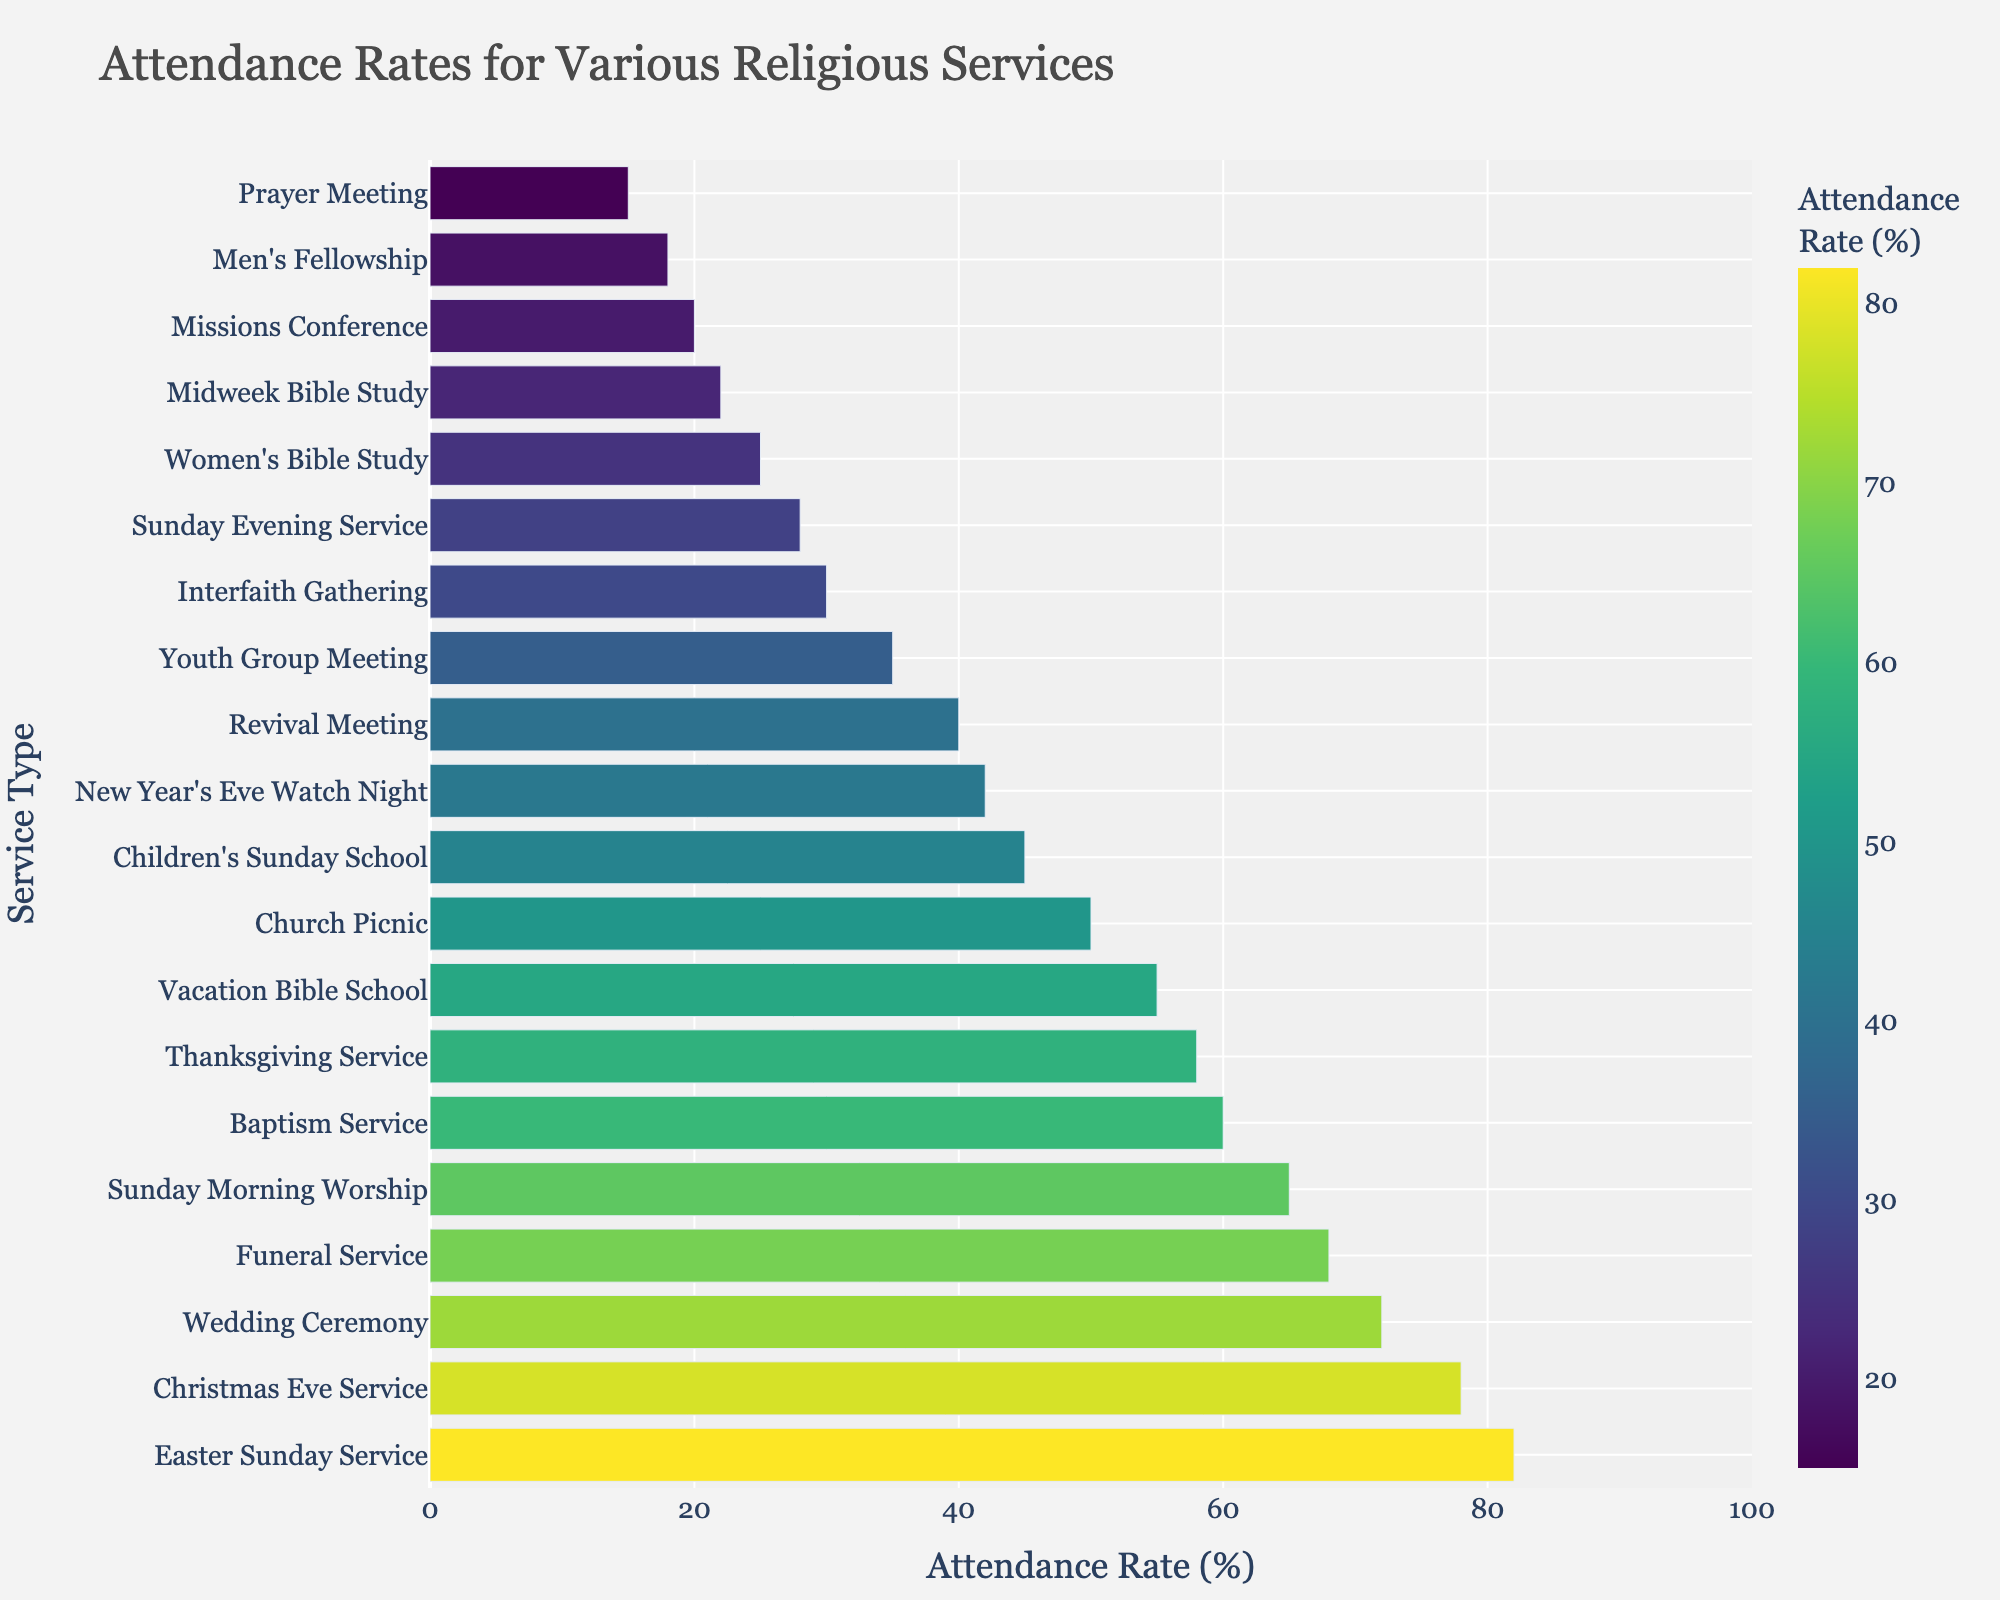What's the attendance rate for the Easter Sunday Service? Find the bar labeled "Easter Sunday Service" and read its length for the attendance rate.
Answer: 82 Which service type has the lowest attendance rate? Identify the shortest bar on the chart, which corresponds to 15% attendance.
Answer: Prayer Meeting How many service types have attendance rates higher than 70%? Count the number of bars with attendance rates greater than 70%.
Answer: 3 What is the difference in attendance rates between the Sunday Evening Service and the Interfaith Gathering? Subtract the attendance rate of the Sunday Evening Service (28%) from the Interfaith Gathering (30%).
Answer: 2 Which service has a higher attendance rate, Baptism Service or Wedding Ceremony? Compare the lengths of the bars for Baptism Service (60%) and Wedding Ceremony (72%).
Answer: Wedding Ceremony What is the average attendance rate for services with rates below 50%? Identify the services with rates below 50% and calculate the average: (Sunday Evening Service, Midweek Bible Study, Youth Group Meeting, Men's Fellowship, Women's Bible Study, Prayer Meeting, Interfaith Gathering, Missions Conference). Average = (28 + 22 + 35 + 18 + 25 + 15 + 30 + 20) / 8 = 193 / 8 = 24.125
Answer: 24.125 By how much does the attendance rate of the Funeral Service exceed that of the Revival Meeting? Subtract the attendance rate of the Revival Meeting (40%) from the Funeral Service (68%).
Answer: 28 Which service type has the closest attendance rate to the Thanksgiving Service? Identify the bar closest in length to the Thanksgiving Service (58%) and compare.
Answer: Vacation Bible School What is the median attendance rate among all service types? Order the attendance rates and find the middle value or the average of the middle two values if even in number. Median of (15, 18, 20, 22, 25, 28, 30, 35, 40, 42, 45, 50, 55, 58, 60, 65, 68, 72, 78, 82) = (42 + 45) / 2 = 87 / 2 = 43.5
Answer: 43.5 